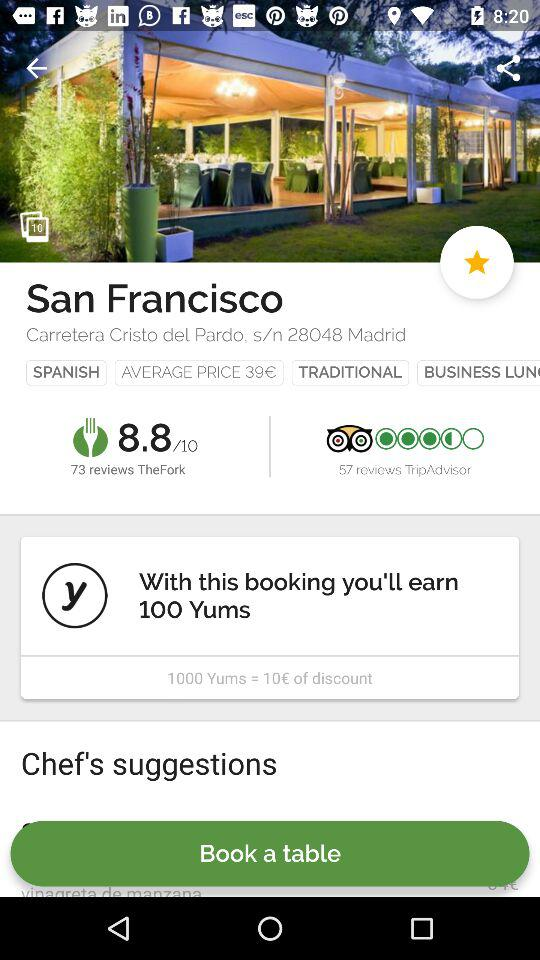How can I add a chef recommendation?
When the provided information is insufficient, respond with <no answer>. <no answer> 